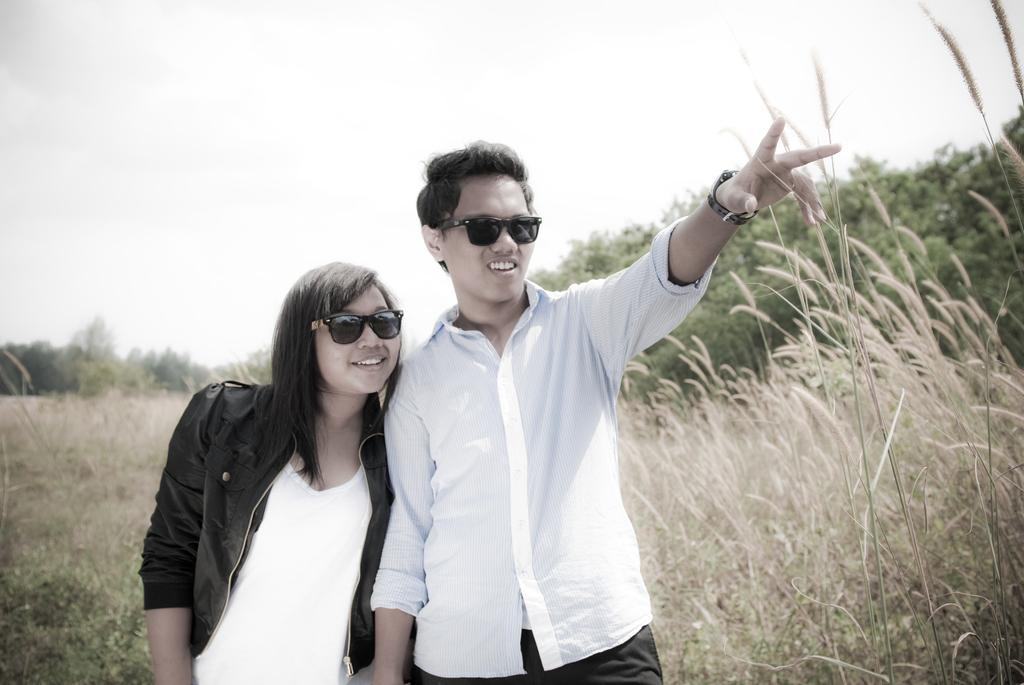How many people are in the image? There are a few people in the image. What type of natural elements can be seen in the image? There are trees and plants in the image. What is visible in the background of the image? The sky is visible in the image. What type of voice can be heard coming from the trees in the image? There is no voice coming from the trees in the image, as trees do not produce sounds. 